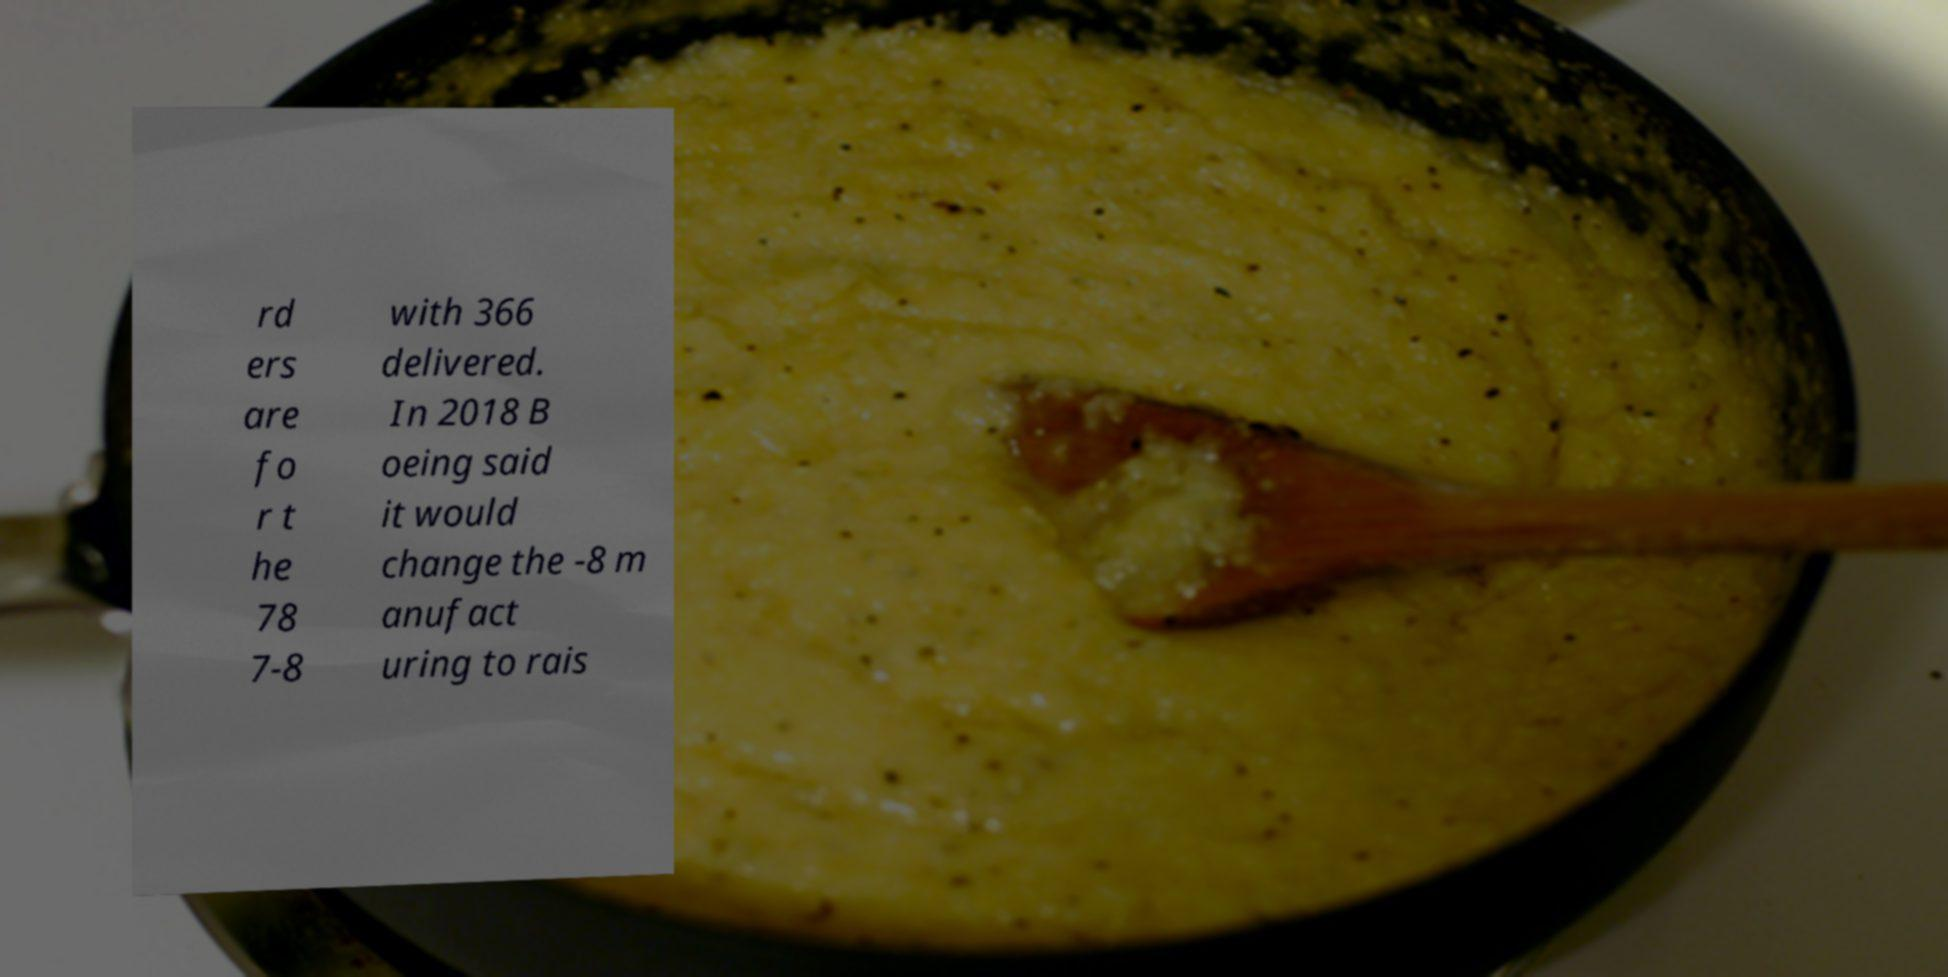Can you accurately transcribe the text from the provided image for me? rd ers are fo r t he 78 7-8 with 366 delivered. In 2018 B oeing said it would change the -8 m anufact uring to rais 